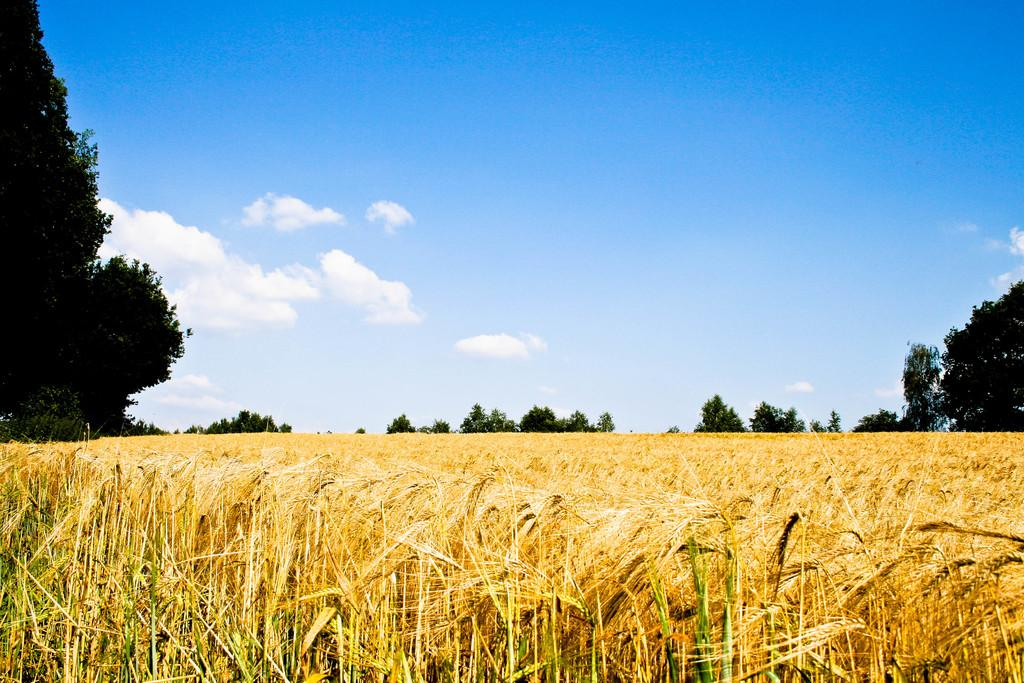What is the main setting of the image? There is a field in the image. What can be seen in the background of the field? There are trees in the background of the image. What is visible in the sky in the image? The sky is visible in the background of the image. What type of weather can be inferred from the image? Clouds are present in the sky, suggesting that it might be a partly cloudy day. What type of afterthought does the queen have while wearing her suit in the image? There is no queen or suit present in the image; it features a field with trees and clouds in the sky. 